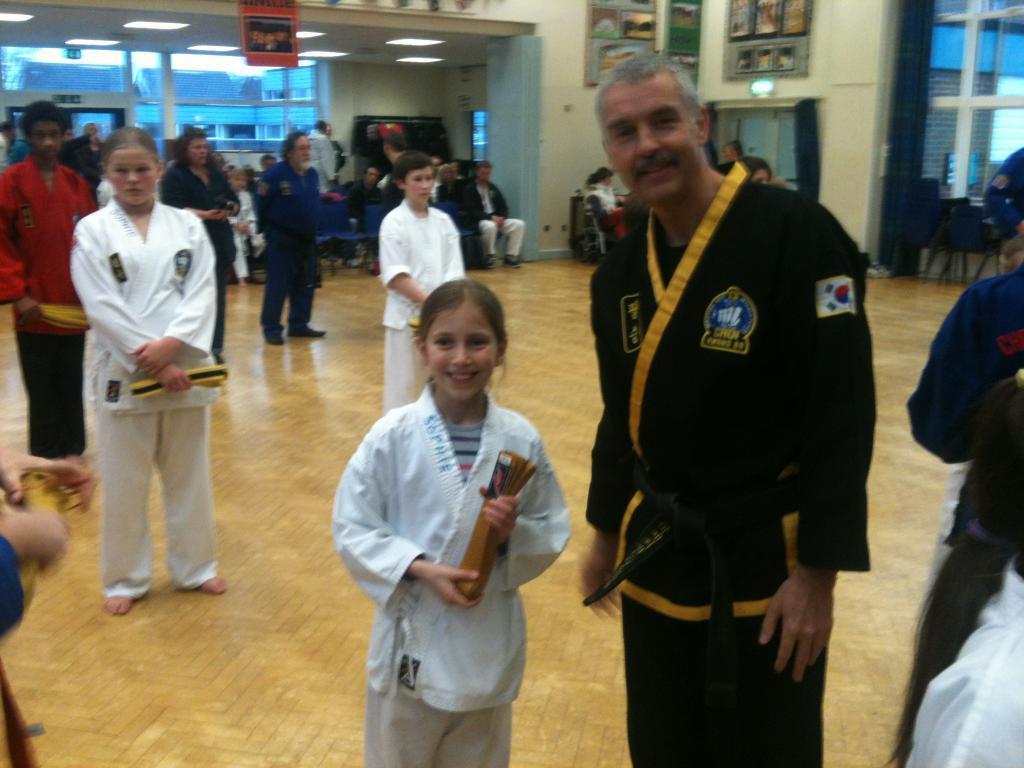Describe this image in one or two sentences. As we can see in the image there are few people here and there, wall, photo frames, lights, door and chairs. 